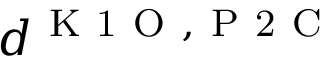<formula> <loc_0><loc_0><loc_500><loc_500>d ^ { K 1 O , P 2 C }</formula> 